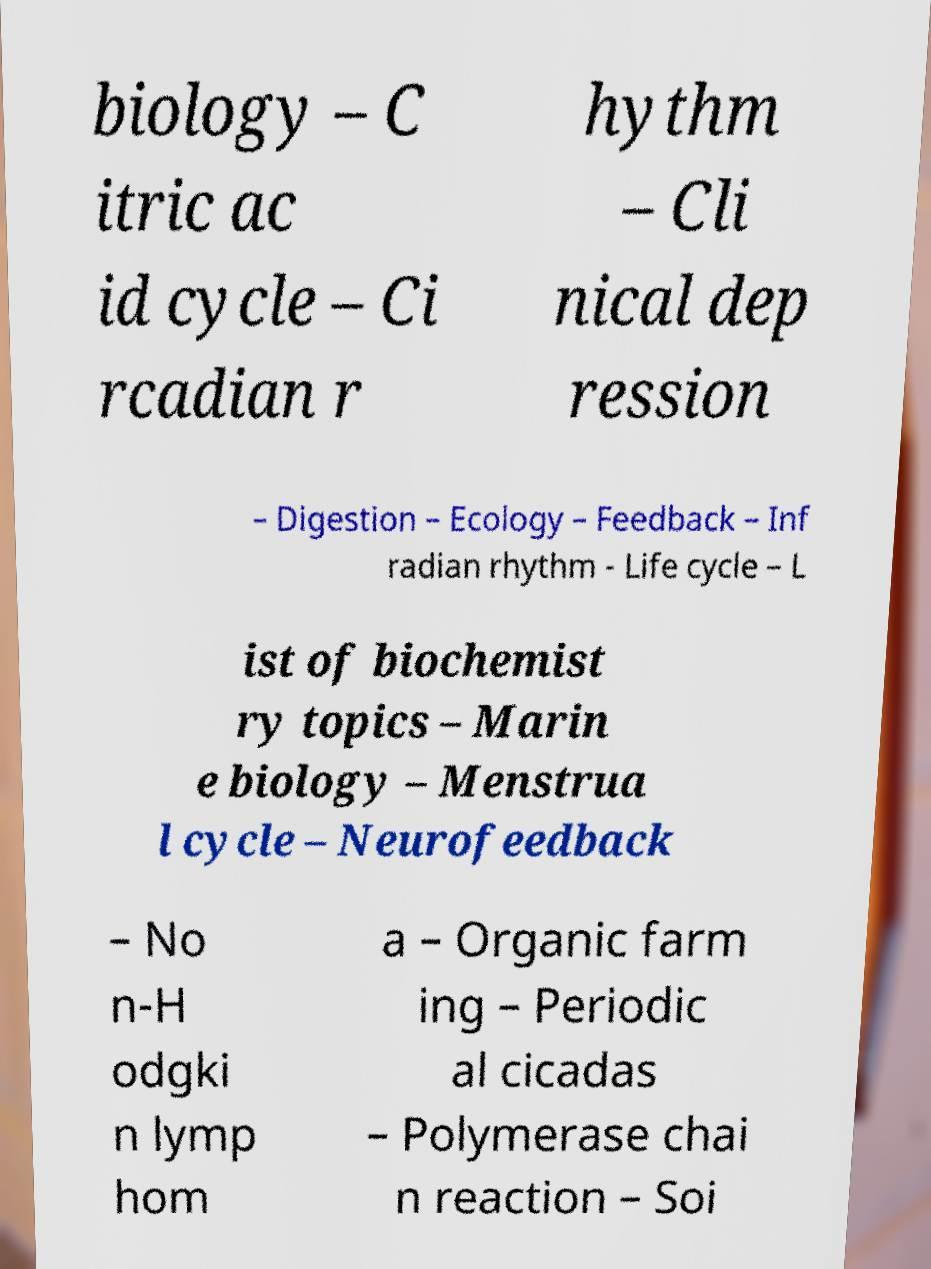What messages or text are displayed in this image? I need them in a readable, typed format. biology – C itric ac id cycle – Ci rcadian r hythm – Cli nical dep ression – Digestion – Ecology – Feedback – Inf radian rhythm - Life cycle – L ist of biochemist ry topics – Marin e biology – Menstrua l cycle – Neurofeedback – No n-H odgki n lymp hom a – Organic farm ing – Periodic al cicadas – Polymerase chai n reaction – Soi 